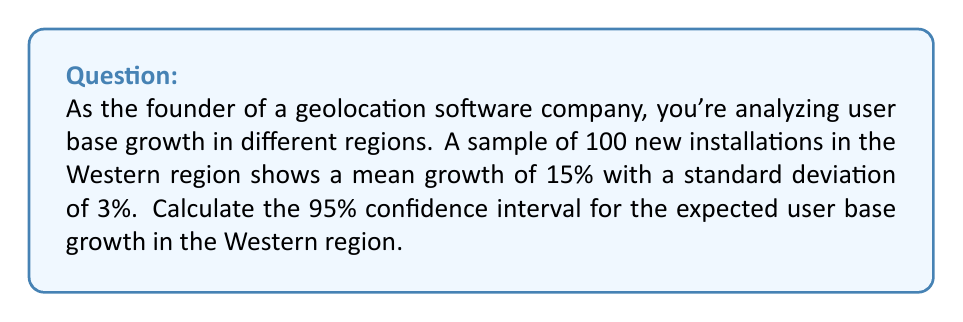Could you help me with this problem? To calculate the confidence interval, we'll follow these steps:

1. Identify the known values:
   - Sample size (n) = 100
   - Sample mean (x̄) = 15%
   - Sample standard deviation (s) = 3%
   - Confidence level = 95% (z-score = 1.96)

2. Calculate the standard error (SE) of the mean:
   $$ SE = \frac{s}{\sqrt{n}} = \frac{3\%}{\sqrt{100}} = 0.3\% $$

3. Determine the margin of error (ME):
   $$ ME = z \times SE = 1.96 \times 0.3\% = 0.588\% $$

4. Calculate the confidence interval:
   Lower bound: $$ 15\% - 0.588\% = 14.412\% $$
   Upper bound: $$ 15\% + 0.588\% = 15.588\% $$

5. Round the results to two decimal places:
   Confidence Interval: (14.41%, 15.59%)

Therefore, we can be 95% confident that the true population mean for user base growth in the Western region falls between 14.41% and 15.59%.
Answer: (14.41%, 15.59%) 